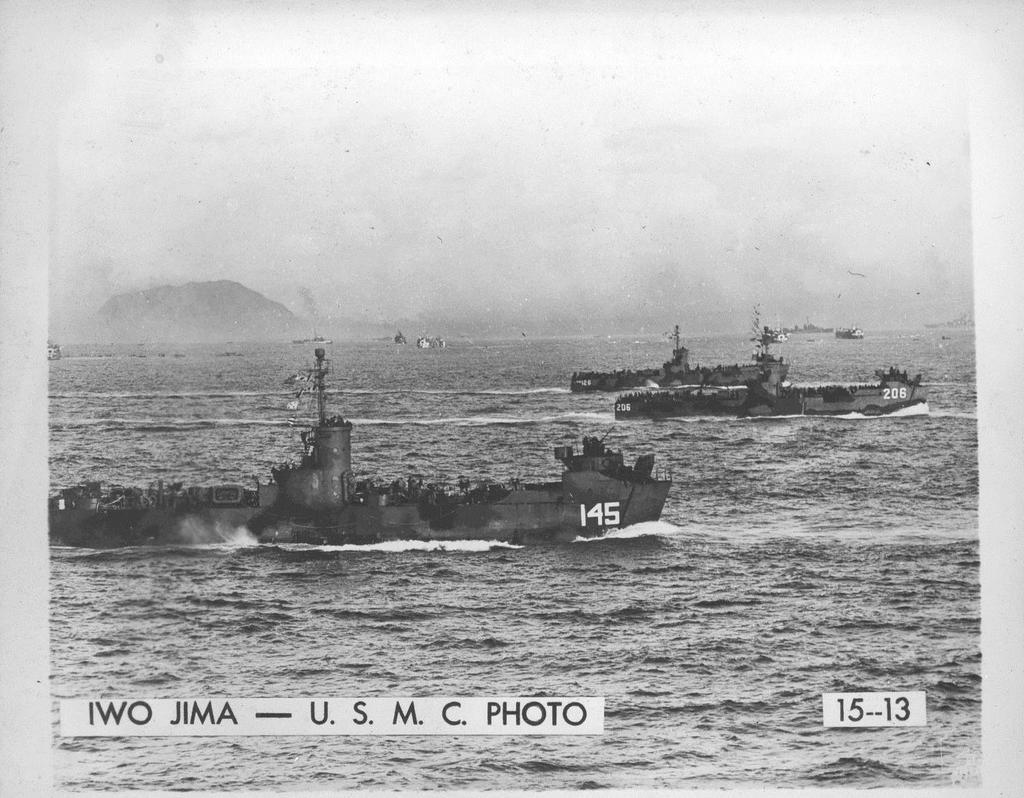<image>
Present a compact description of the photo's key features. An old picture of two boats at IWO JIMA are seen gliding across the sea 